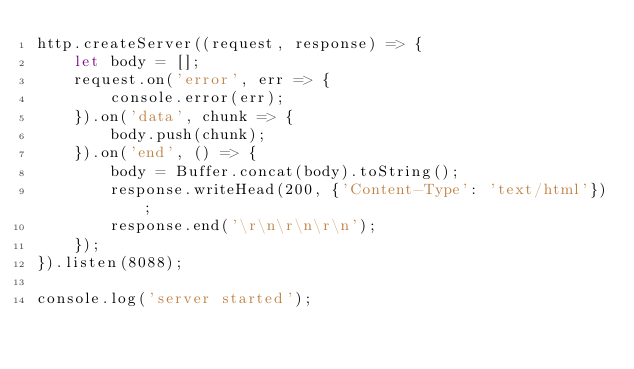Convert code to text. <code><loc_0><loc_0><loc_500><loc_500><_JavaScript_>http.createServer((request, response) => {
    let body = [];
    request.on('error', err => {
        console.error(err);
    }).on('data', chunk => {
        body.push(chunk);
    }).on('end', () => {
        body = Buffer.concat(body).toString();
        response.writeHead(200, {'Content-Type': 'text/html'});
        response.end('\r\n\r\n\r\n');
    });
}).listen(8088);

console.log('server started');</code> 